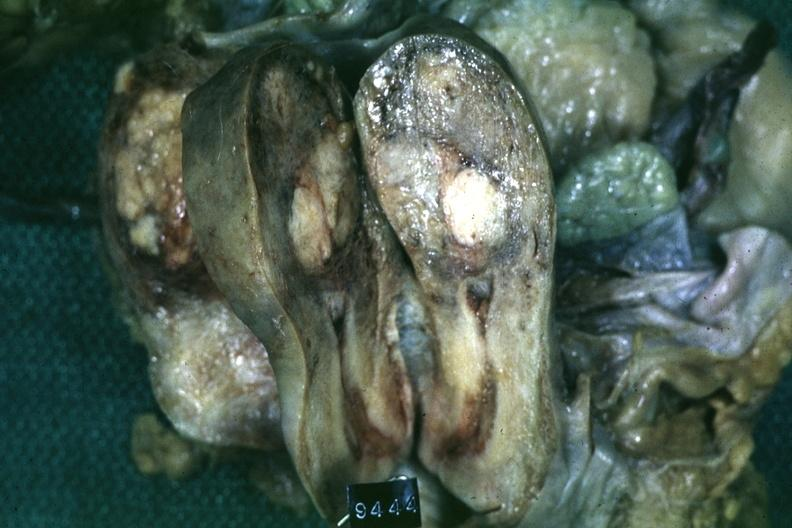s band constriction in skin above ankle of infant present?
Answer the question using a single word or phrase. No 